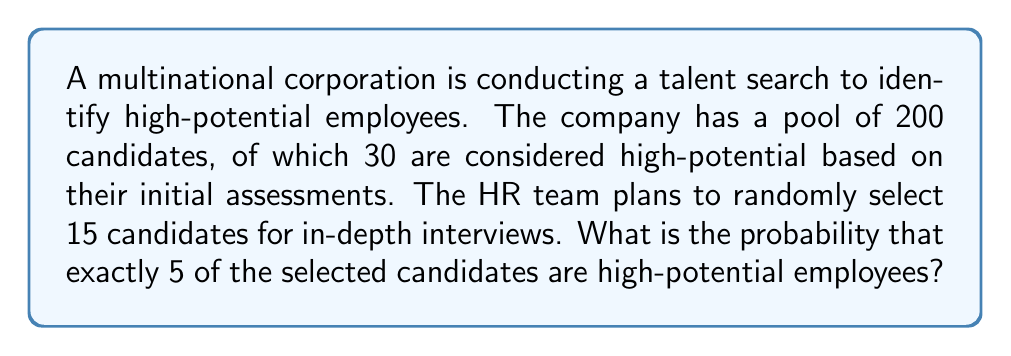Can you answer this question? To solve this problem, we need to use the hypergeometric distribution, which is appropriate for sampling without replacement from a finite population.

Let's define our variables:
$N = 200$ (total number of candidates)
$K = 30$ (number of high-potential candidates)
$n = 15$ (number of candidates selected for interviews)
$k = 5$ (number of high-potential candidates we want to select)

The probability mass function for the hypergeometric distribution is:

$$P(X = k) = \frac{\binom{K}{k} \binom{N-K}{n-k}}{\binom{N}{n}}$$

Where:
$\binom{K}{k}$ is the number of ways to choose $k$ high-potential candidates from $K$ total high-potential candidates
$\binom{N-K}{n-k}$ is the number of ways to choose the remaining $(n-k)$ candidates from the $(N-K)$ non-high-potential candidates
$\binom{N}{n}$ is the total number of ways to choose $n$ candidates from $N$ total candidates

Let's calculate each part:

1. $\binom{K}{k} = \binom{30}{5} = 142,506$
2. $\binom{N-K}{n-k} = \binom{170}{10} = 1,937,752,355$
3. $\binom{N}{n} = \binom{200}{15} = 1,609,344,100,205$

Now, let's substitute these values into our probability mass function:

$$P(X = 5) = \frac{142,506 \times 1,937,752,355}{1,609,344,100,205} \approx 0.1715$$
Answer: The probability of selecting exactly 5 high-potential employees out of 15 randomly selected candidates is approximately 0.1715 or 17.15%. 